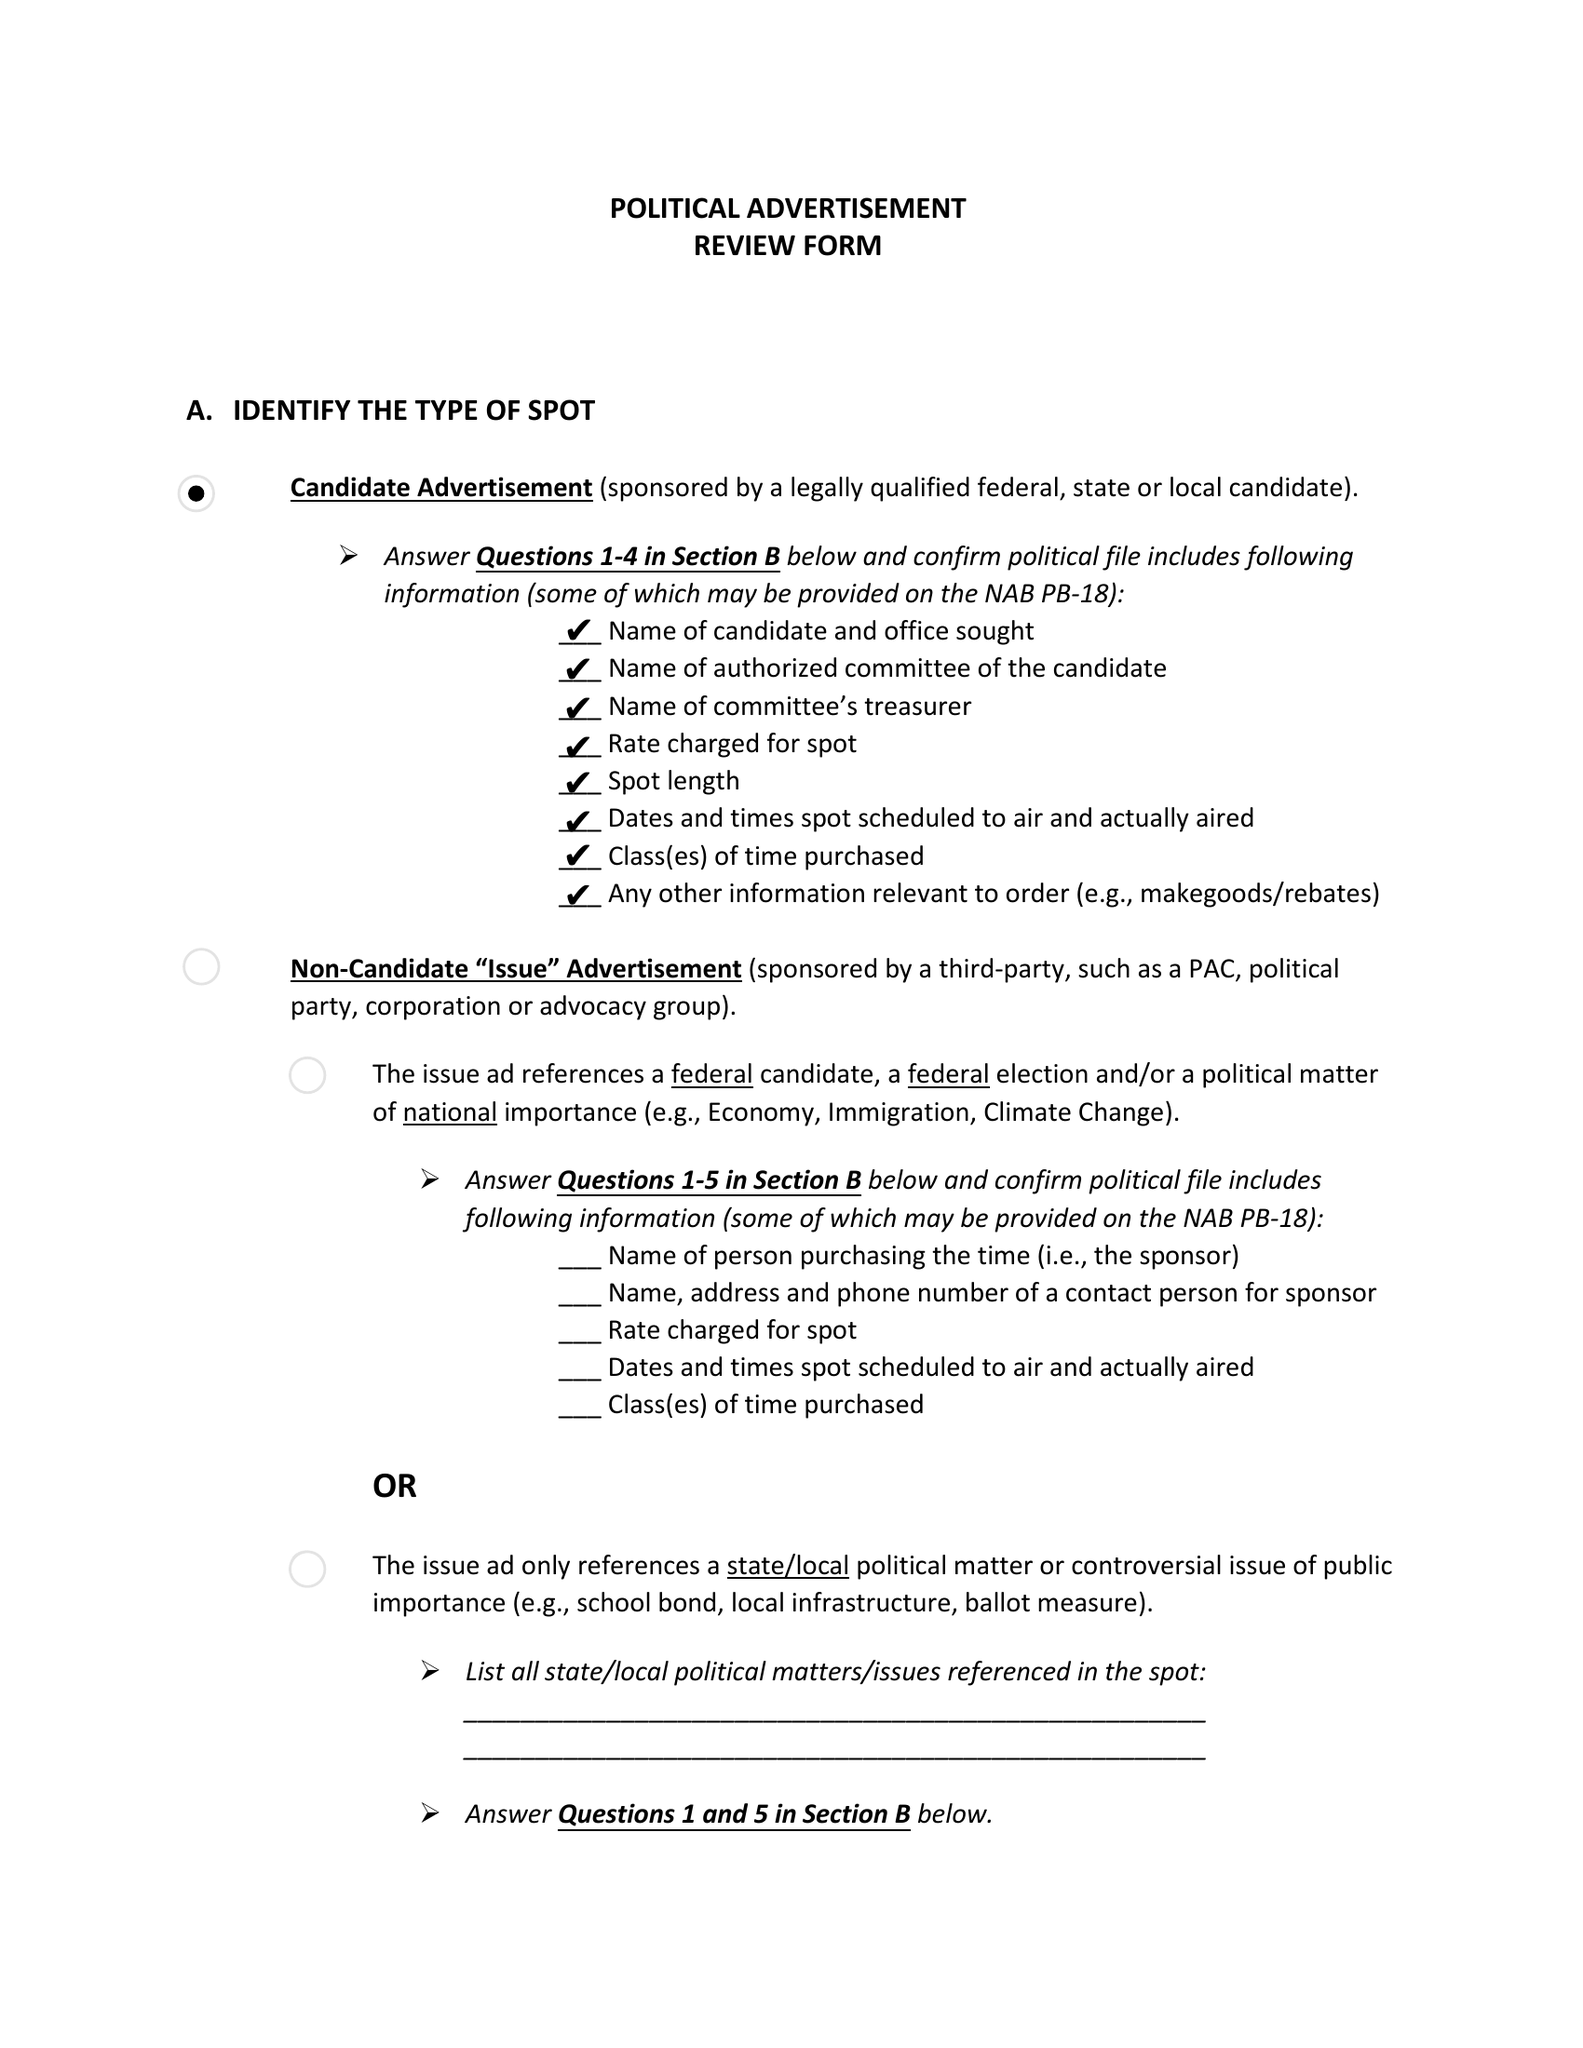What is the value for the flight_from?
Answer the question using a single word or phrase. None 